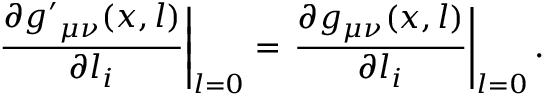Convert formula to latex. <formula><loc_0><loc_0><loc_500><loc_500>\frac { \partial { g ^ { \prime } } _ { \mu \nu } ( x , l ) } { \partial l _ { i } } \right | _ { l = 0 } = \frac { \partial g _ { \mu \nu } ( x , l ) } { \partial l _ { i } } \right | _ { l = 0 } .</formula> 